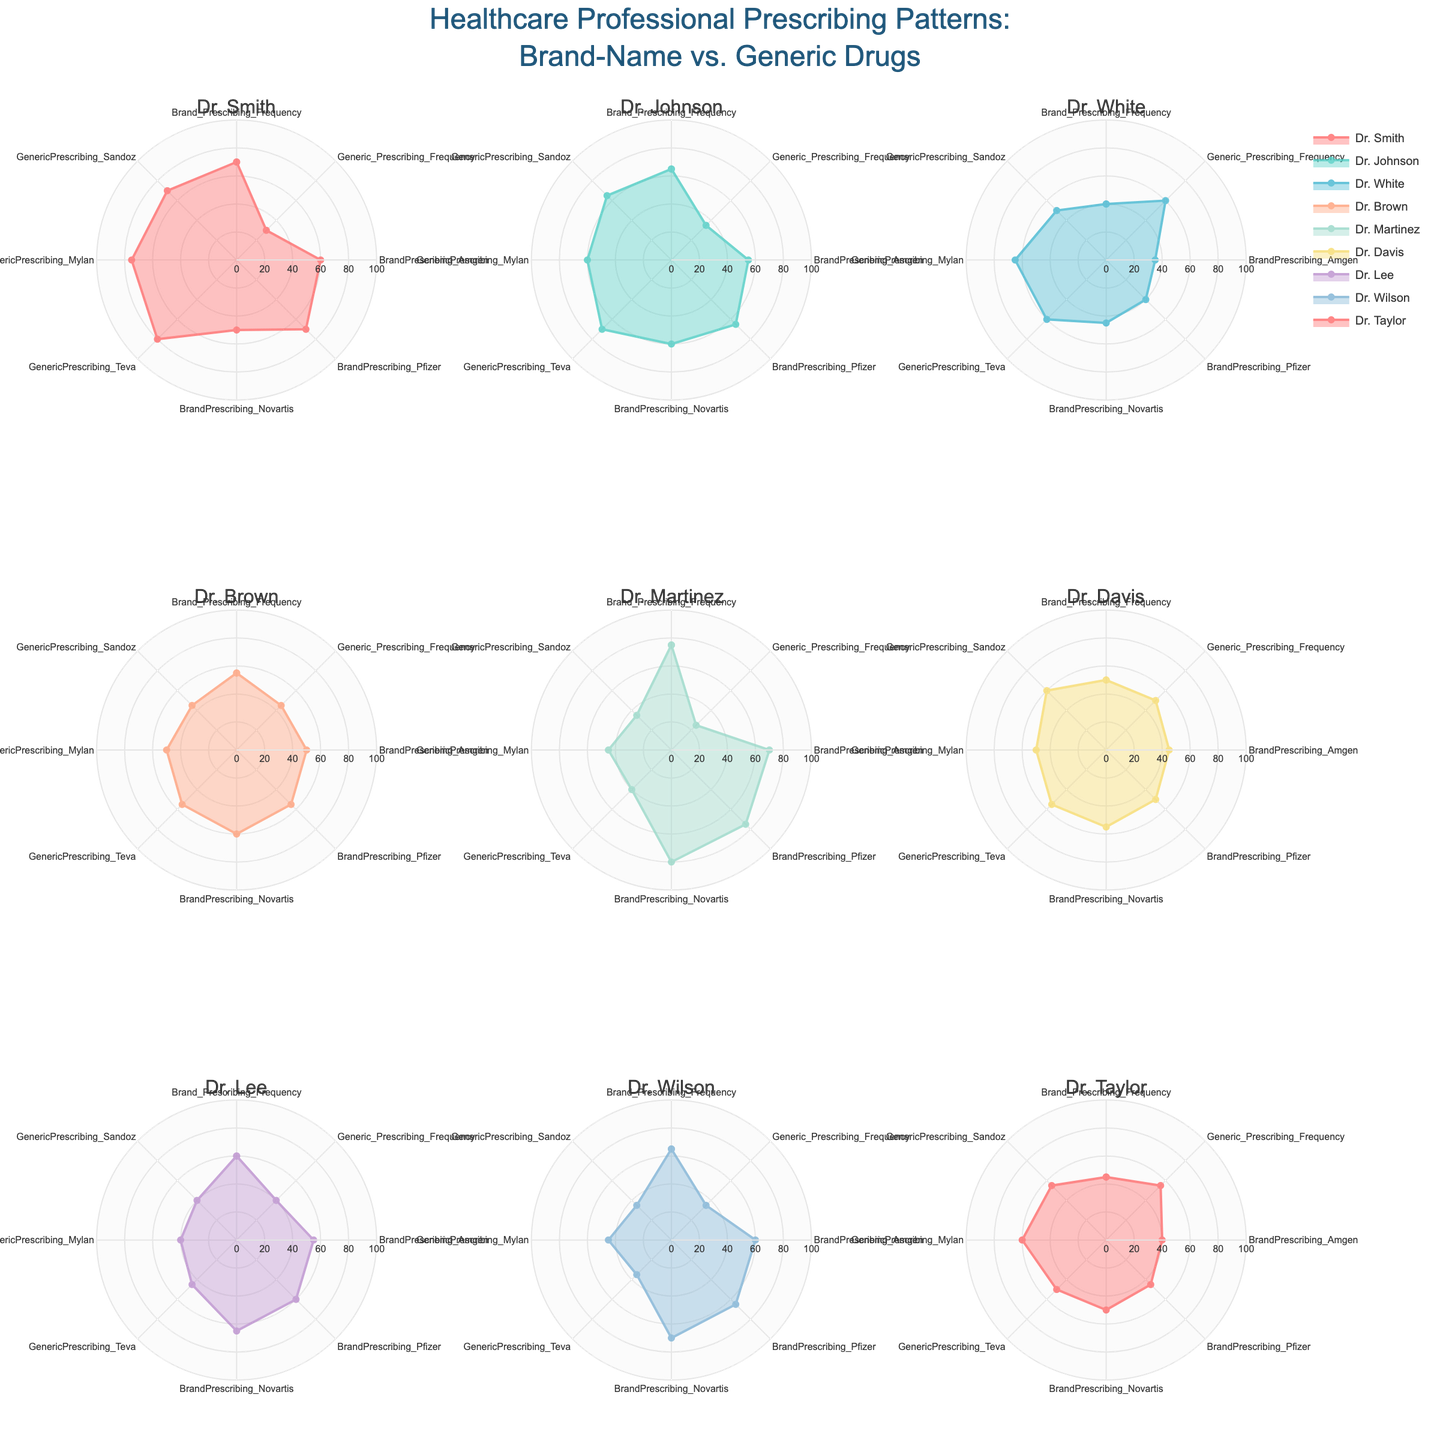What's the title of the plot? The title of the plot is clearly indicated at the top of the figure. It reads: "Healthcare Professional Prescribing Patterns: Brand-Name vs. Generic Drugs".
Answer: Healthcare Professional Prescribing Patterns: Brand-Name vs. Generic Drugs Which healthcare professional prescribes generic drugs the most frequently? By looking at the radar charts, specifically at the 'Generic_Prescribing_Frequency' axis, it is noticeable that Dr. White has the highest value (60).
Answer: Dr. White Comparing Dr. Smith and Dr. Martinez, who prescribes brand-name drugs more frequently for Amgen? Dr. Smith's radar plot shows a value of 60 for 'BrandPrescribing_Amgen', whereas Dr. Martinez's plot shows a value of 70 for the same category. Therefore, Dr. Martinez prescribes brand-name drugs for Amgen more frequently.
Answer: Dr. Martinez Who has the smallest difference in brand-name and generic prescribing frequencies? Calculating the difference between 'Brand_Prescribing_Frequency' and 'Generic_Prescribing_Frequency' for all HCPs, Dr. Davis has the smallest difference (50 - 50 = 0).
Answer: Dr. Davis What is the average brand-name prescribing frequency across all professionals? Summing up all values for 'Brand_Prescribing_Frequency' (70 + 65 + 40 + 55 + 75 + 50 + 60 + 65 + 45) equals 525. Dividing by 9 (number of professionals) gives an average of 58.33.
Answer: 58.33 Which healthcare professional shows the highest variability in their prescriptions between different brand-name drug companies (Amgen, Pfizer, Novartis)? By assessing the range of values on the radar charts for 'BrandPrescribing_Amgen', 'BrandPrescribing_Pfizer', and 'BrandPrescribing_Novartis', Dr. Smith shows considerable variability, with values of 60, 70, and 50 respectively.
Answer: Dr. Smith Who has a higher generic prescribing frequency for Teva, Dr. Brown or Dr. Martinez? Comparing the 'GenericPrescribing_Teva' values from their radar charts, Dr. Brown has a value of 55, while Dr. Martinez has a value of 40.
Answer: Dr. Brown Which doctor has the least balanced prescribing pattern between brand-name and generic drugs? Dr. Martinez has a large difference between 'Brand_Prescribing_Frequency' (75) and 'Generic_Prescribing_Frequency' (25), indicating an unbalanced prescribing pattern.
Answer: Dr. Martinez 